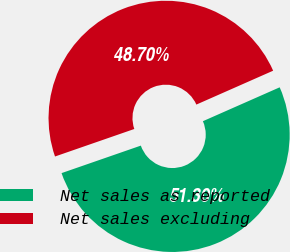Convert chart to OTSL. <chart><loc_0><loc_0><loc_500><loc_500><pie_chart><fcel>Net sales as reported<fcel>Net sales excluding<nl><fcel>51.3%<fcel>48.7%<nl></chart> 